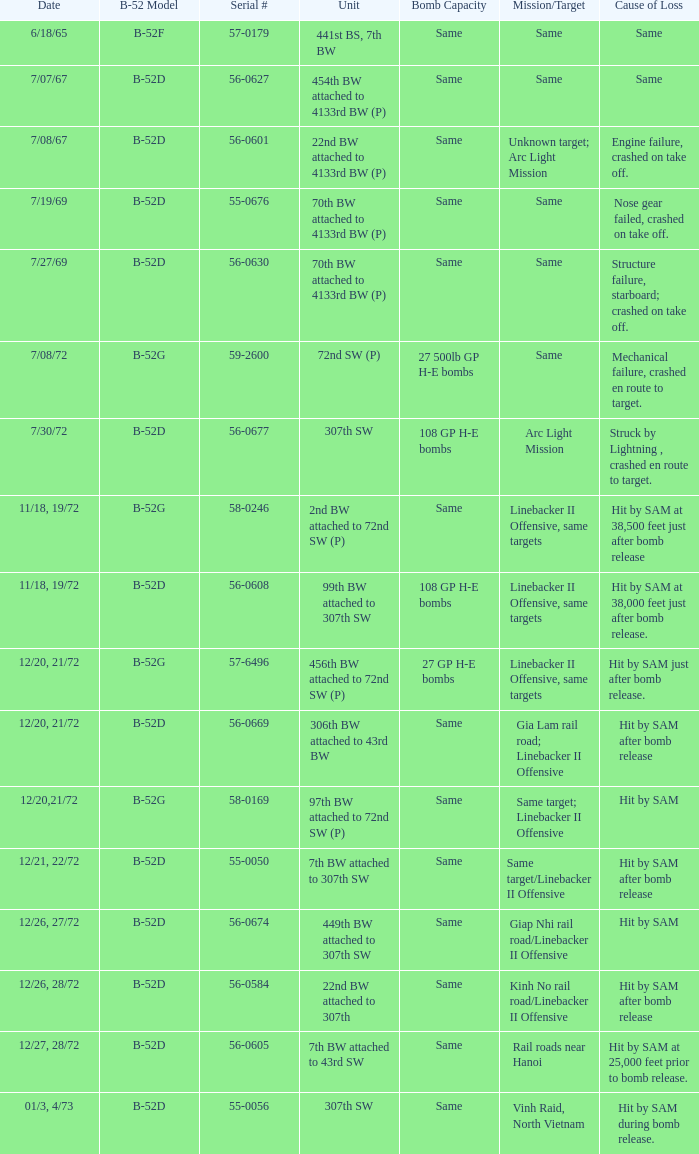When hit by sam at 38,500 feet just after bomb release was the cause of loss what is the mission/target? Linebacker II Offensive, same targets. Could you help me parse every detail presented in this table? {'header': ['Date', 'B-52 Model', 'Serial #', 'Unit', 'Bomb Capacity', 'Mission/Target', 'Cause of Loss'], 'rows': [['6/18/65', 'B-52F', '57-0179', '441st BS, 7th BW', 'Same', 'Same', 'Same'], ['7/07/67', 'B-52D', '56-0627', '454th BW attached to 4133rd BW (P)', 'Same', 'Same', 'Same'], ['7/08/67', 'B-52D', '56-0601', '22nd BW attached to 4133rd BW (P)', 'Same', 'Unknown target; Arc Light Mission', 'Engine failure, crashed on take off.'], ['7/19/69', 'B-52D', '55-0676', '70th BW attached to 4133rd BW (P)', 'Same', 'Same', 'Nose gear failed, crashed on take off.'], ['7/27/69', 'B-52D', '56-0630', '70th BW attached to 4133rd BW (P)', 'Same', 'Same', 'Structure failure, starboard; crashed on take off.'], ['7/08/72', 'B-52G', '59-2600', '72nd SW (P)', '27 500lb GP H-E bombs', 'Same', 'Mechanical failure, crashed en route to target.'], ['7/30/72', 'B-52D', '56-0677', '307th SW', '108 GP H-E bombs', 'Arc Light Mission', 'Struck by Lightning , crashed en route to target.'], ['11/18, 19/72', 'B-52G', '58-0246', '2nd BW attached to 72nd SW (P)', 'Same', 'Linebacker II Offensive, same targets', 'Hit by SAM at 38,500 feet just after bomb release'], ['11/18, 19/72', 'B-52D', '56-0608', '99th BW attached to 307th SW', '108 GP H-E bombs', 'Linebacker II Offensive, same targets', 'Hit by SAM at 38,000 feet just after bomb release.'], ['12/20, 21/72', 'B-52G', '57-6496', '456th BW attached to 72nd SW (P)', '27 GP H-E bombs', 'Linebacker II Offensive, same targets', 'Hit by SAM just after bomb release.'], ['12/20, 21/72', 'B-52D', '56-0669', '306th BW attached to 43rd BW', 'Same', 'Gia Lam rail road; Linebacker II Offensive', 'Hit by SAM after bomb release'], ['12/20,21/72', 'B-52G', '58-0169', '97th BW attached to 72nd SW (P)', 'Same', 'Same target; Linebacker II Offensive', 'Hit by SAM'], ['12/21, 22/72', 'B-52D', '55-0050', '7th BW attached to 307th SW', 'Same', 'Same target/Linebacker II Offensive', 'Hit by SAM after bomb release'], ['12/26, 27/72', 'B-52D', '56-0674', '449th BW attached to 307th SW', 'Same', 'Giap Nhi rail road/Linebacker II Offensive', 'Hit by SAM'], ['12/26, 28/72', 'B-52D', '56-0584', '22nd BW attached to 307th', 'Same', 'Kinh No rail road/Linebacker II Offensive', 'Hit by SAM after bomb release'], ['12/27, 28/72', 'B-52D', '56-0605', '7th BW attached to 43rd SW', 'Same', 'Rail roads near Hanoi', 'Hit by SAM at 25,000 feet prior to bomb release.'], ['01/3, 4/73', 'B-52D', '55-0056', '307th SW', 'Same', 'Vinh Raid, North Vietnam', 'Hit by SAM during bomb release.']]} 